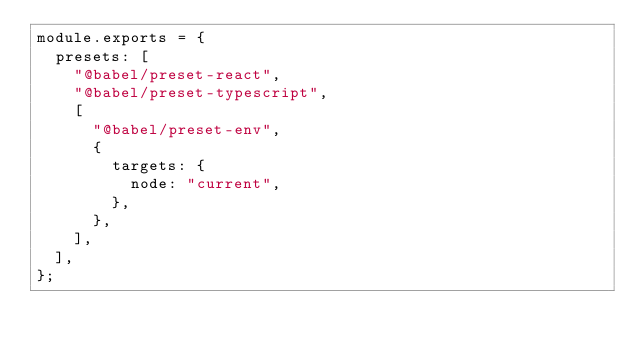<code> <loc_0><loc_0><loc_500><loc_500><_JavaScript_>module.exports = {
  presets: [
    "@babel/preset-react",
    "@babel/preset-typescript",
    [
      "@babel/preset-env",
      {
        targets: {
          node: "current",
        },
      },
    ],
  ],
};
</code> 